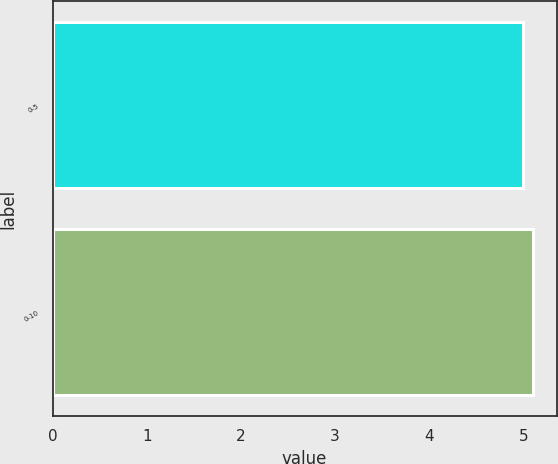Convert chart. <chart><loc_0><loc_0><loc_500><loc_500><bar_chart><fcel>0-5<fcel>0-10<nl><fcel>5<fcel>5.1<nl></chart> 